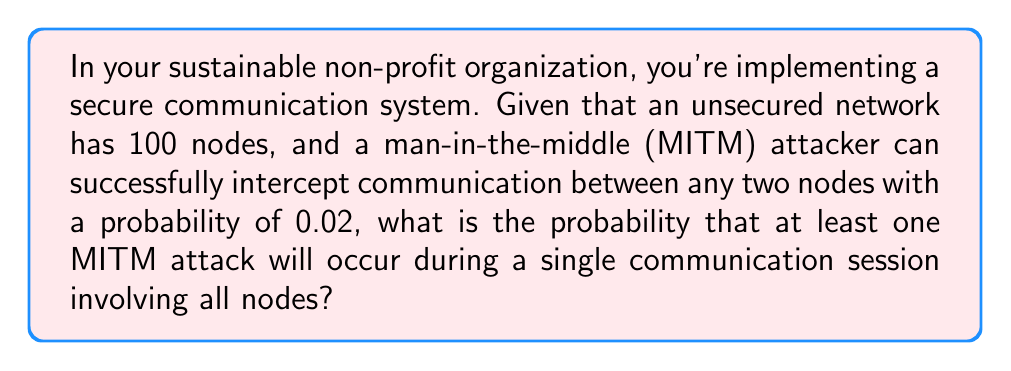Teach me how to tackle this problem. Let's approach this step-by-step:

1) First, we need to calculate the total number of possible connections between nodes. With 100 nodes, the number of connections is given by the combination formula:

   $$\binom{100}{2} = \frac{100!}{2!(100-2)!} = 4950$$

2) For each connection, the probability of a successful MITM attack is 0.02, and the probability of no attack is 1 - 0.02 = 0.98.

3) For no MITM attacks to occur at all, every single connection must be secure. The probability of this is:

   $$0.98^{4950}$$

4) Therefore, the probability of at least one MITM attack occurring is the complement of this:

   $$1 - 0.98^{4950}$$

5) Let's calculate this:

   $$1 - 0.98^{4950} \approx 1 - 5.7 \times 10^{-44}$$

6) This is extremely close to 1, meaning it's almost certain that at least one MITM attack will occur.
Answer: $1 - 0.98^{4950} \approx 0.9999999999999999999999999999999999999999943$ 